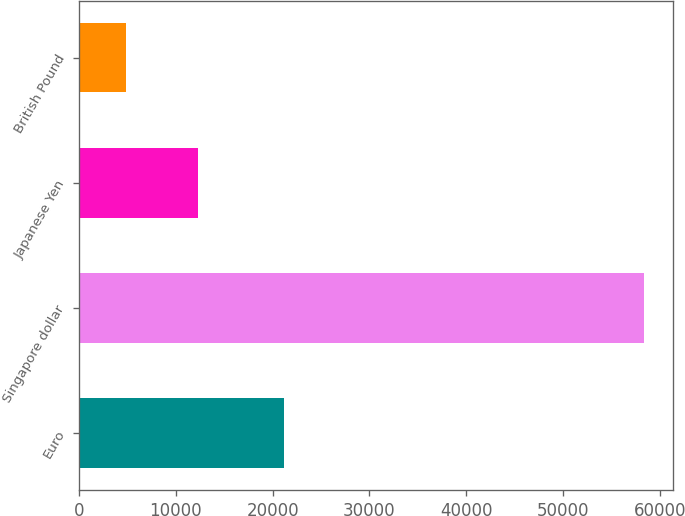Convert chart to OTSL. <chart><loc_0><loc_0><loc_500><loc_500><bar_chart><fcel>Euro<fcel>Singapore dollar<fcel>Japanese Yen<fcel>British Pound<nl><fcel>21190<fcel>58420<fcel>12268<fcel>4889<nl></chart> 